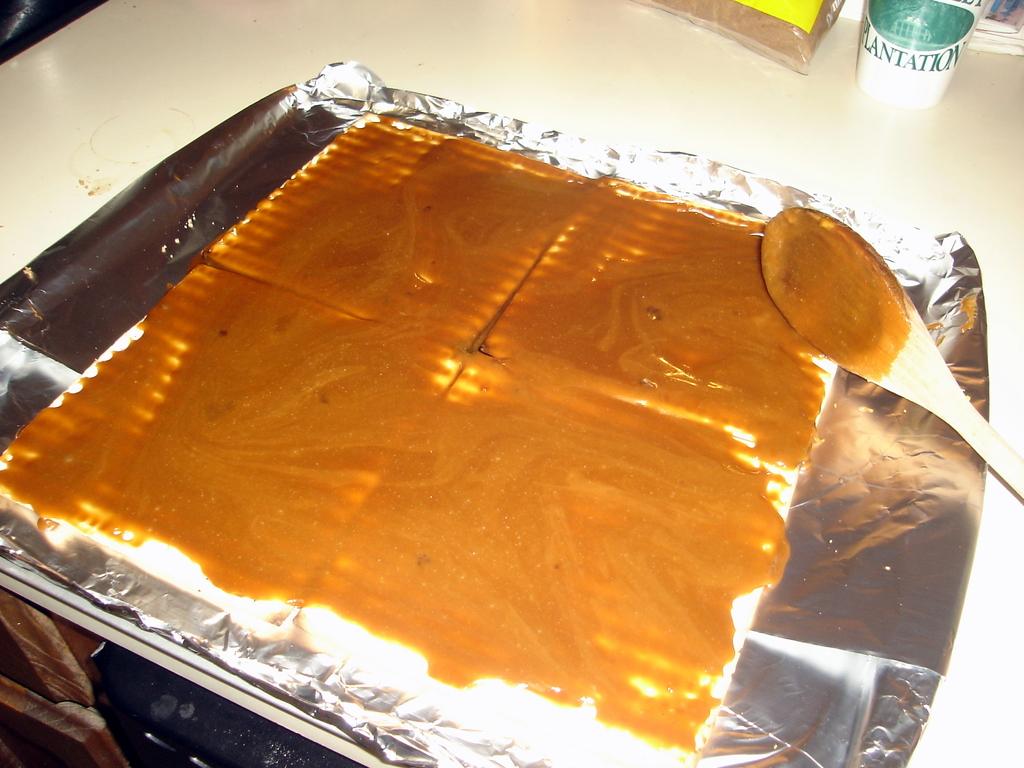Whats the word on the top right bottle?
Your answer should be very brief. Plantation. What language is the green word?
Give a very brief answer. English. 